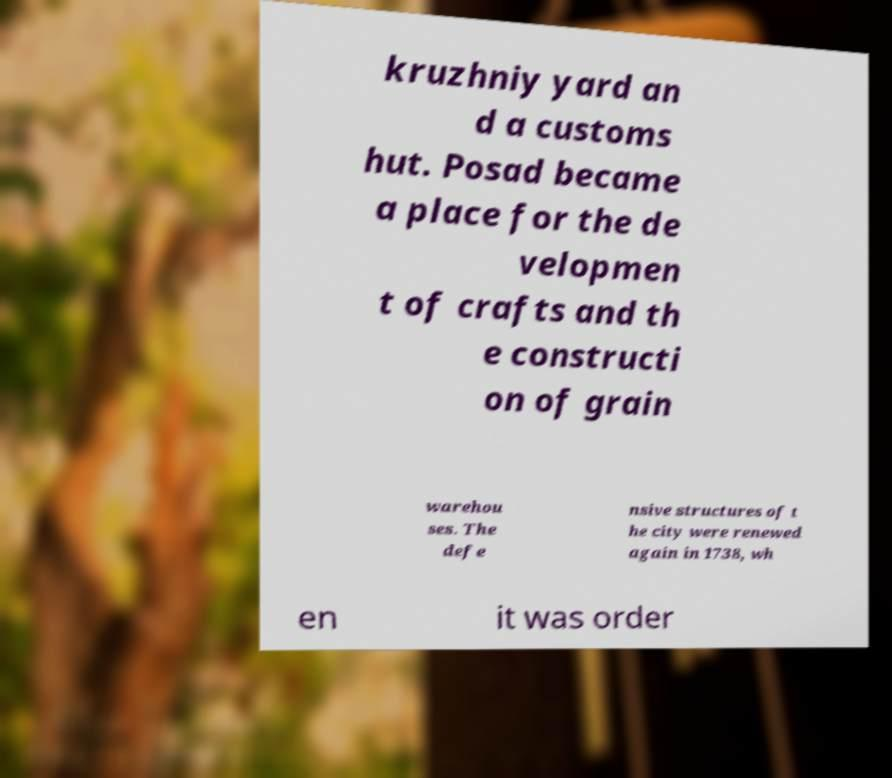There's text embedded in this image that I need extracted. Can you transcribe it verbatim? kruzhniy yard an d a customs hut. Posad became a place for the de velopmen t of crafts and th e constructi on of grain warehou ses. The defe nsive structures of t he city were renewed again in 1738, wh en it was order 